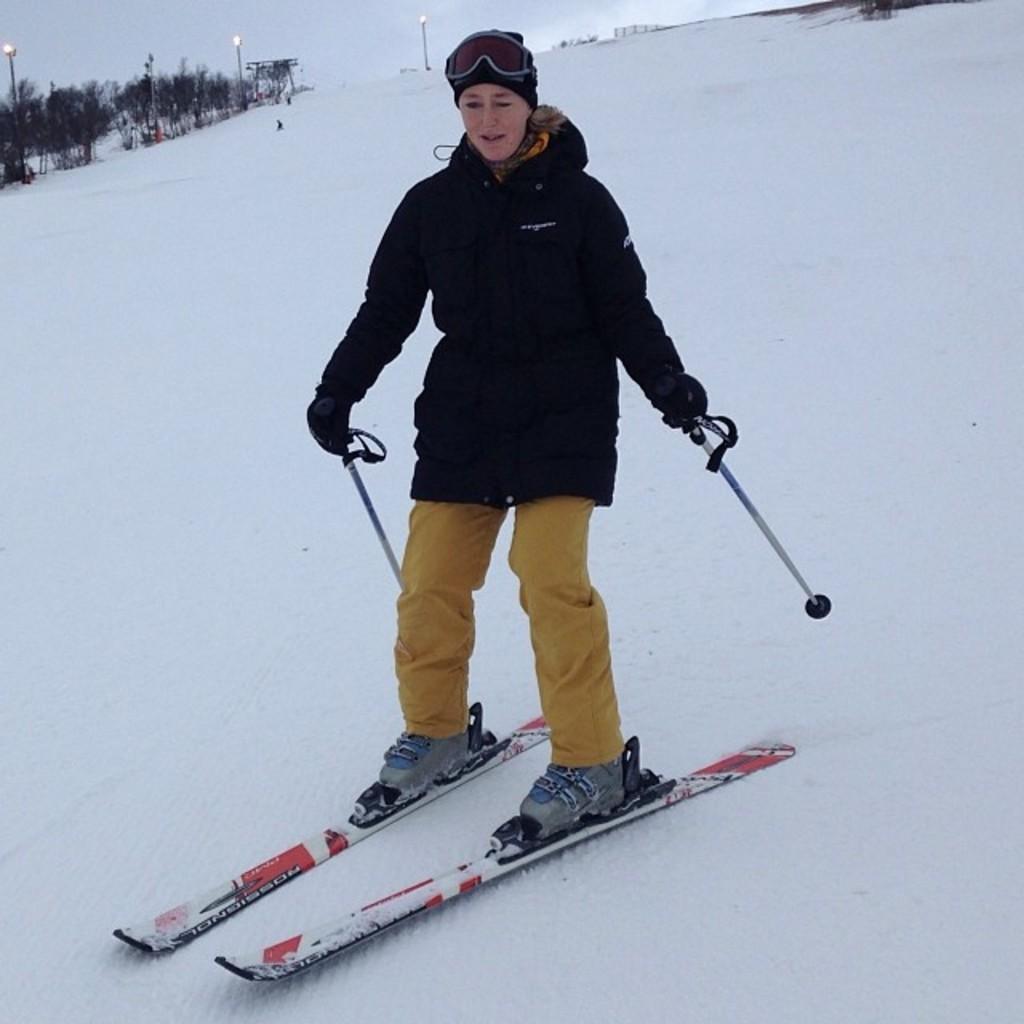Please provide a concise description of this image. In this picture there is a lady in the center of the image, she is ice skating and there is snow around the area of the image and there are trees in the top left side of the image. 